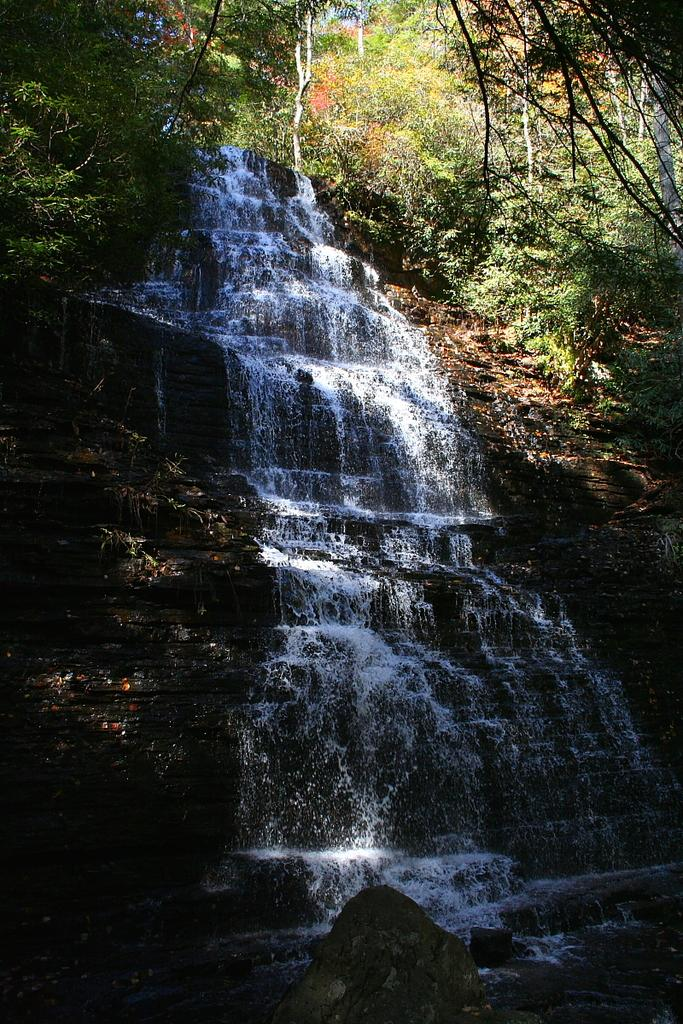What natural feature is the main subject of the image? There is a waterfall in the image. What type of vegetation can be seen in the image? There are trees in the image. What is located at the bottom of the image? Rocks are present at the bottom of the image. How many passengers are visible in the image? There are no passengers present in the image; it features a waterfall, trees, and rocks. What type of flesh can be seen in the image? There is no flesh present in the image; it features a waterfall, trees, and rocks. 